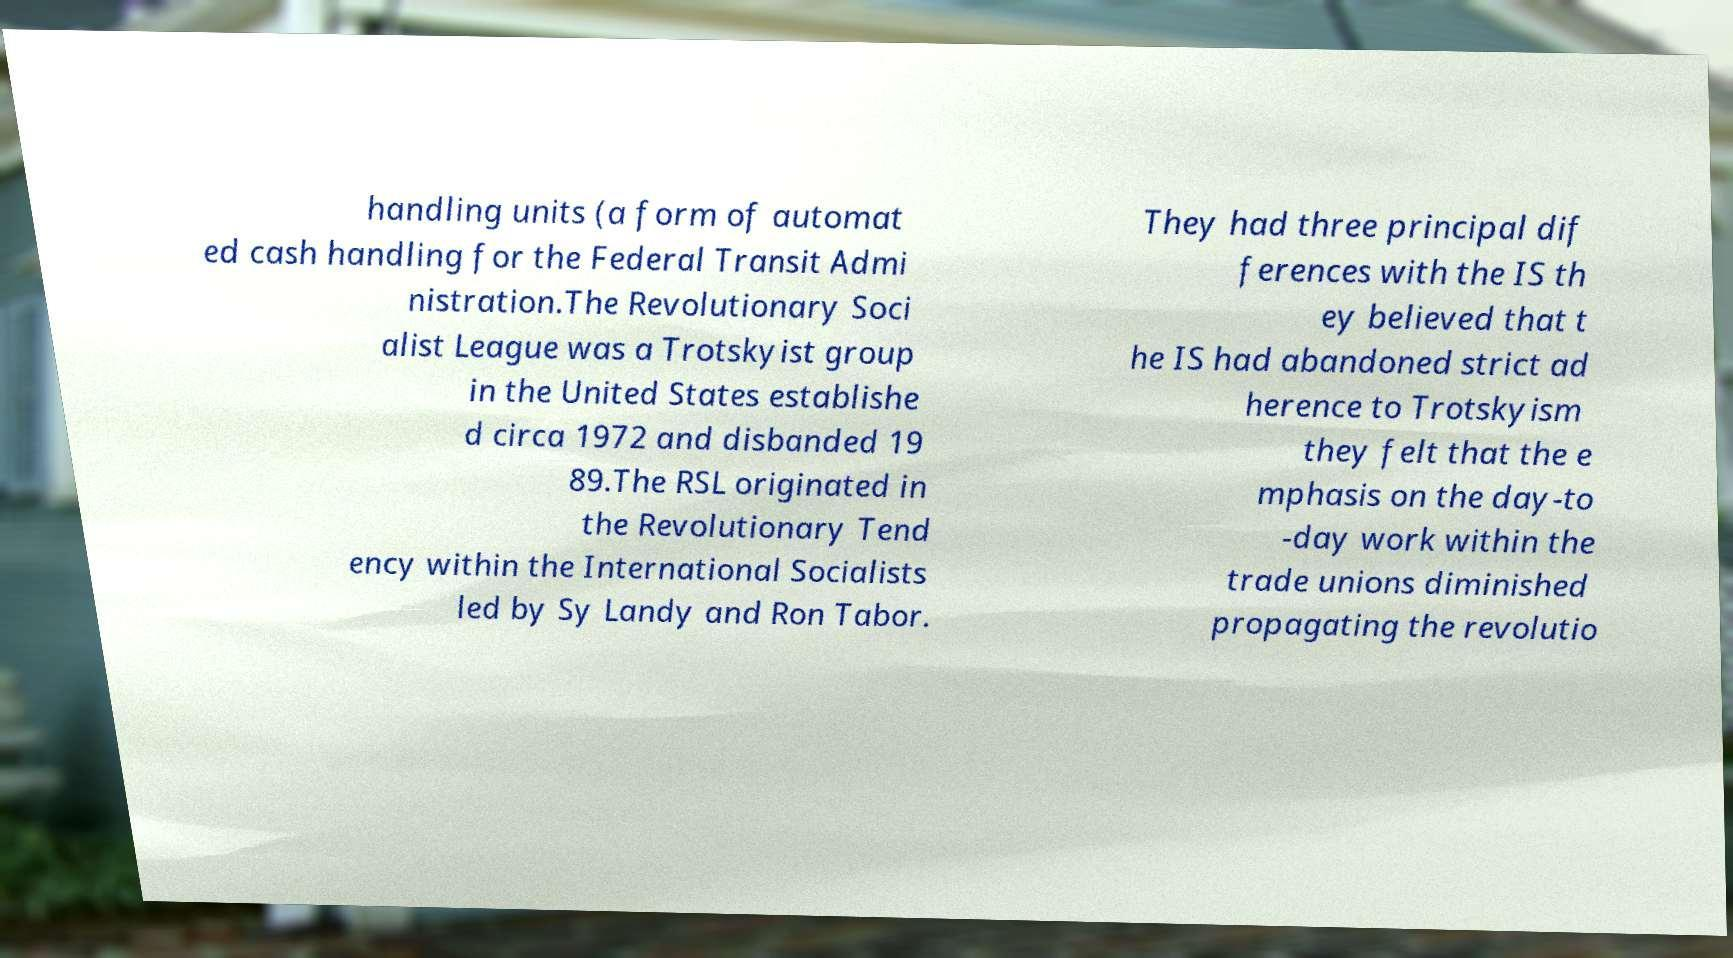Please identify and transcribe the text found in this image. handling units (a form of automat ed cash handling for the Federal Transit Admi nistration.The Revolutionary Soci alist League was a Trotskyist group in the United States establishe d circa 1972 and disbanded 19 89.The RSL originated in the Revolutionary Tend ency within the International Socialists led by Sy Landy and Ron Tabor. They had three principal dif ferences with the IS th ey believed that t he IS had abandoned strict ad herence to Trotskyism they felt that the e mphasis on the day-to -day work within the trade unions diminished propagating the revolutio 